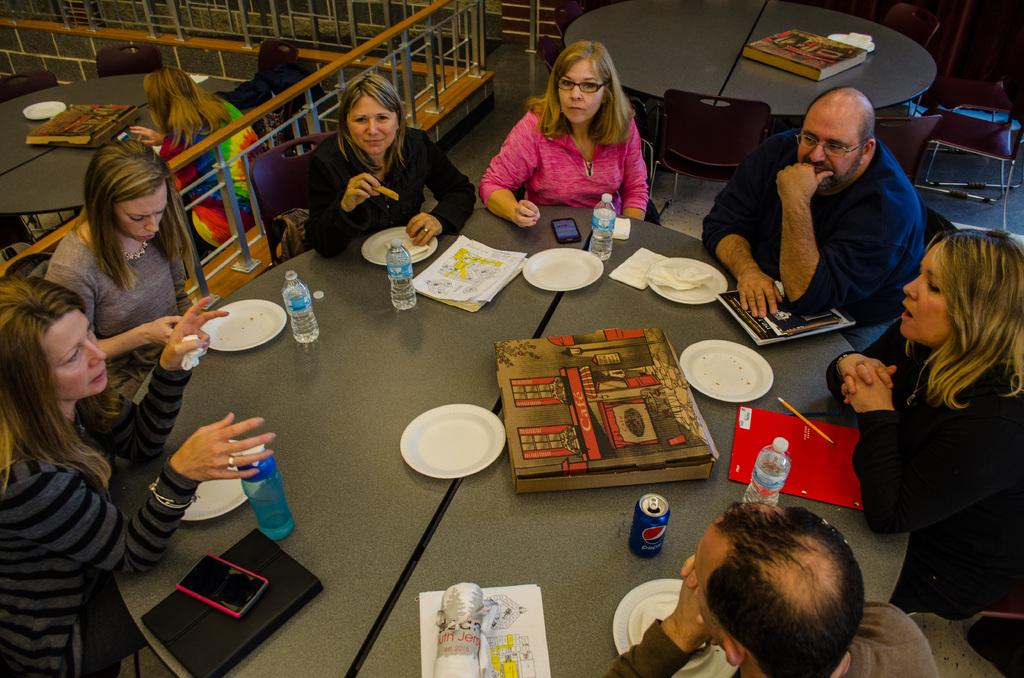How many people are present in the image? There are people in the image, but the exact number cannot be determined from the provided facts. What objects are present on the tables in the image? There are plates and bottles visible on the tables in the image. What type of electronic devices can be seen in the image? Mobile phones are present in the image. What kind of barrier is visible in the image? There is a fence in the image. What type of furniture is present in the image? Chairs and tables are present in the image. Can you describe any other objects visible in the image? There are some other objects in the image, but their specific nature cannot be determined from the provided facts. What type of coat is draped over the seat in the image? There is no coat or seat present in the image. What direction are the people in the image looking? The provided facts do not mention the direction in which the people are looking. 